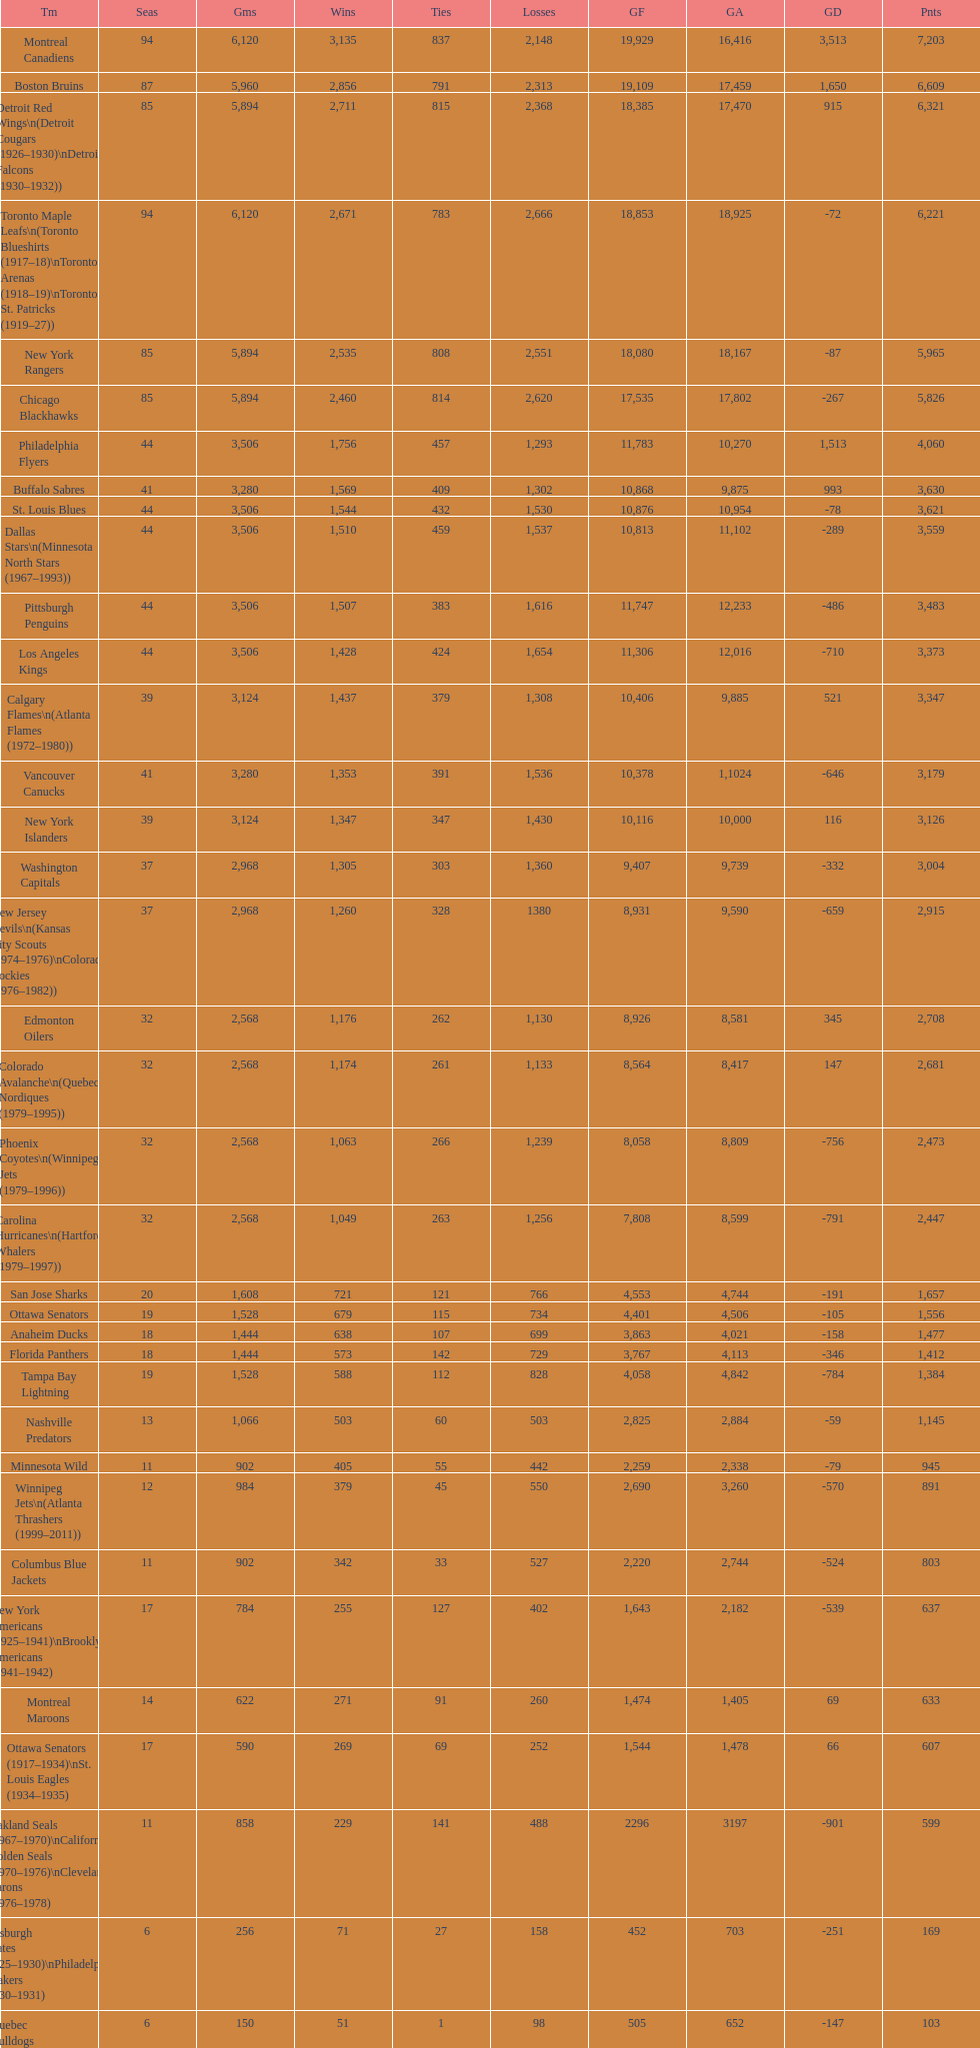Who has the least amount of losses? Montreal Wanderers. 